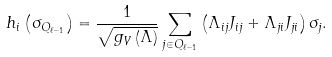<formula> <loc_0><loc_0><loc_500><loc_500>h _ { i } \left ( \sigma _ { Q _ { \ell - 1 } } \right ) = \frac { 1 } { \sqrt { g _ { V } \left ( \Lambda \right ) } } \sum _ { j \in Q _ { \ell - 1 } } \left ( \Lambda _ { i j } J _ { i j } + \Lambda _ { j i } J _ { j i } \right ) \sigma _ { j } .</formula> 